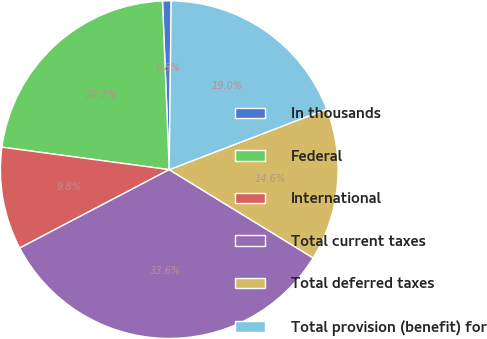Convert chart to OTSL. <chart><loc_0><loc_0><loc_500><loc_500><pie_chart><fcel>In thousands<fcel>Federal<fcel>International<fcel>Total current taxes<fcel>Total deferred taxes<fcel>Total provision (benefit) for<nl><fcel>0.82%<fcel>22.24%<fcel>9.81%<fcel>33.56%<fcel>14.6%<fcel>18.97%<nl></chart> 